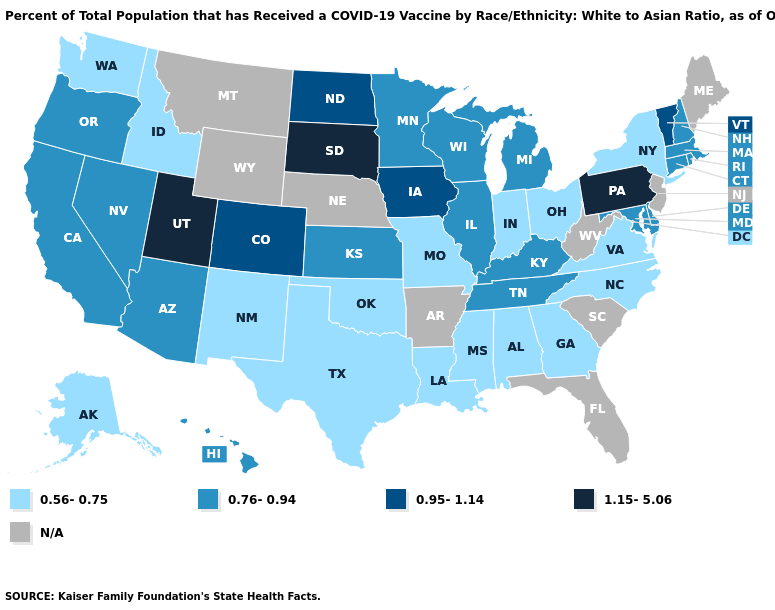Name the states that have a value in the range 0.56-0.75?
Give a very brief answer. Alabama, Alaska, Georgia, Idaho, Indiana, Louisiana, Mississippi, Missouri, New Mexico, New York, North Carolina, Ohio, Oklahoma, Texas, Virginia, Washington. What is the value of Washington?
Answer briefly. 0.56-0.75. What is the value of Georgia?
Be succinct. 0.56-0.75. Does the first symbol in the legend represent the smallest category?
Give a very brief answer. Yes. What is the value of Oregon?
Write a very short answer. 0.76-0.94. What is the lowest value in states that border South Carolina?
Write a very short answer. 0.56-0.75. Which states hav the highest value in the Northeast?
Give a very brief answer. Pennsylvania. Which states have the lowest value in the USA?
Keep it brief. Alabama, Alaska, Georgia, Idaho, Indiana, Louisiana, Mississippi, Missouri, New Mexico, New York, North Carolina, Ohio, Oklahoma, Texas, Virginia, Washington. Name the states that have a value in the range 1.15-5.06?
Keep it brief. Pennsylvania, South Dakota, Utah. Among the states that border Wisconsin , does Iowa have the lowest value?
Answer briefly. No. Does New Mexico have the lowest value in the West?
Keep it brief. Yes. What is the value of Ohio?
Concise answer only. 0.56-0.75. Which states have the lowest value in the USA?
Keep it brief. Alabama, Alaska, Georgia, Idaho, Indiana, Louisiana, Mississippi, Missouri, New Mexico, New York, North Carolina, Ohio, Oklahoma, Texas, Virginia, Washington. What is the value of South Carolina?
Keep it brief. N/A. 